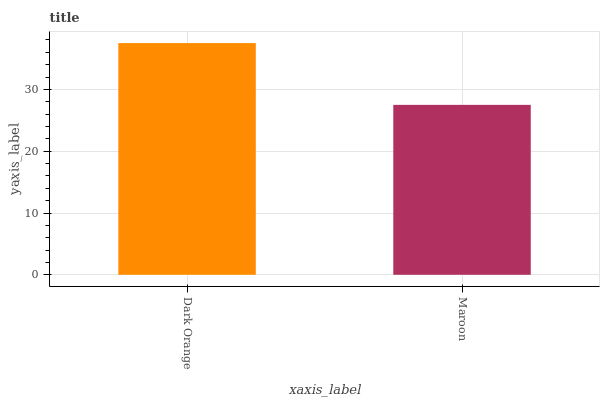Is Maroon the minimum?
Answer yes or no. Yes. Is Dark Orange the maximum?
Answer yes or no. Yes. Is Maroon the maximum?
Answer yes or no. No. Is Dark Orange greater than Maroon?
Answer yes or no. Yes. Is Maroon less than Dark Orange?
Answer yes or no. Yes. Is Maroon greater than Dark Orange?
Answer yes or no. No. Is Dark Orange less than Maroon?
Answer yes or no. No. Is Dark Orange the high median?
Answer yes or no. Yes. Is Maroon the low median?
Answer yes or no. Yes. Is Maroon the high median?
Answer yes or no. No. Is Dark Orange the low median?
Answer yes or no. No. 